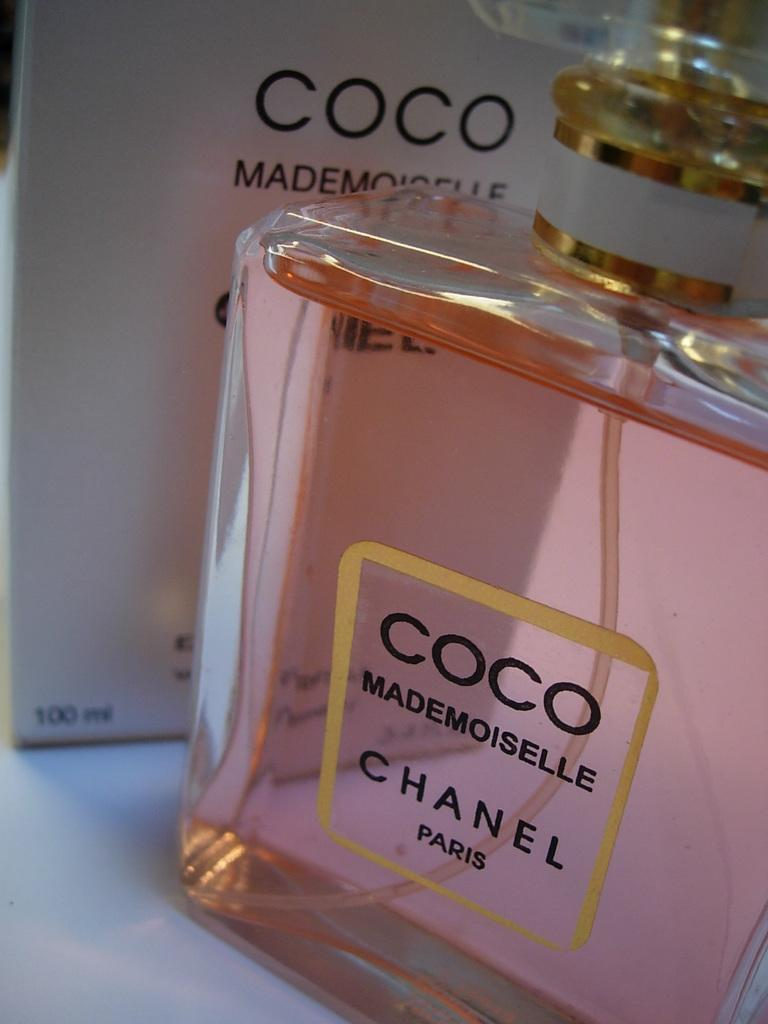<image>
Provide a brief description of the given image. A bottle of perfume the brand is Chanel 